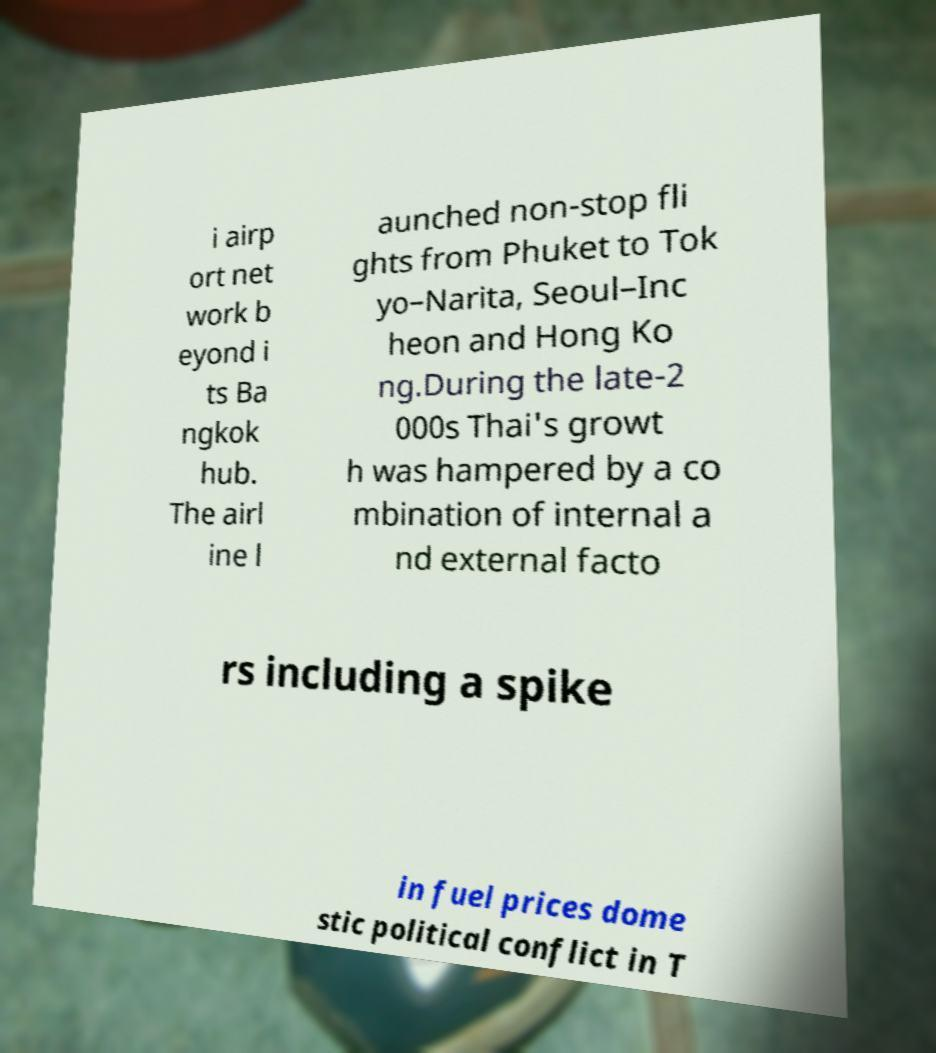What messages or text are displayed in this image? I need them in a readable, typed format. i airp ort net work b eyond i ts Ba ngkok hub. The airl ine l aunched non-stop fli ghts from Phuket to Tok yo–Narita, Seoul–Inc heon and Hong Ko ng.During the late-2 000s Thai's growt h was hampered by a co mbination of internal a nd external facto rs including a spike in fuel prices dome stic political conflict in T 